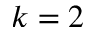Convert formula to latex. <formula><loc_0><loc_0><loc_500><loc_500>k = 2</formula> 